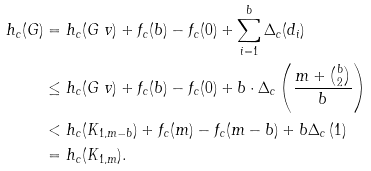<formula> <loc_0><loc_0><loc_500><loc_500>h _ { c } ( G ) & = h _ { c } ( G \ v ) + f _ { c } ( b ) - f _ { c } ( 0 ) + \sum _ { i = 1 } ^ { b } \Delta _ { c } ( d _ { i } ) \\ & \leq h _ { c } ( G \ v ) + f _ { c } ( b ) - f _ { c } ( 0 ) + b \cdot \Delta _ { c } \left ( \frac { m + \binom { b } { 2 } } { b } \right ) \\ & < h _ { c } ( K _ { 1 , m - b } ) + f _ { c } ( m ) - f _ { c } ( m - b ) + b \Delta _ { c } \left ( 1 \right ) \\ & = h _ { c } ( K _ { 1 , m } ) .</formula> 